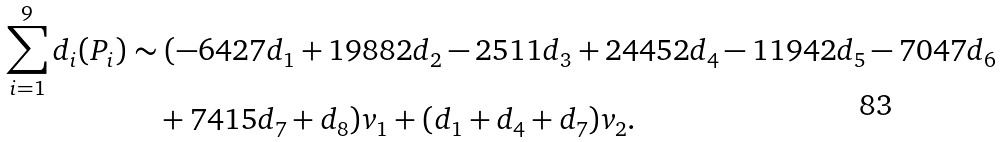Convert formula to latex. <formula><loc_0><loc_0><loc_500><loc_500>\sum _ { i = 1 } ^ { 9 } d _ { i } ( P _ { i } ) & \sim ( - 6 4 2 7 d _ { 1 } + 1 9 8 8 2 d _ { 2 } - 2 5 1 1 d _ { 3 } + 2 4 4 5 2 d _ { 4 } - 1 1 9 4 2 d _ { 5 } - 7 0 4 7 d _ { 6 } \\ & \quad + 7 4 1 5 d _ { 7 } + d _ { 8 } ) v _ { 1 } + ( d _ { 1 } + d _ { 4 } + d _ { 7 } ) v _ { 2 } .</formula> 